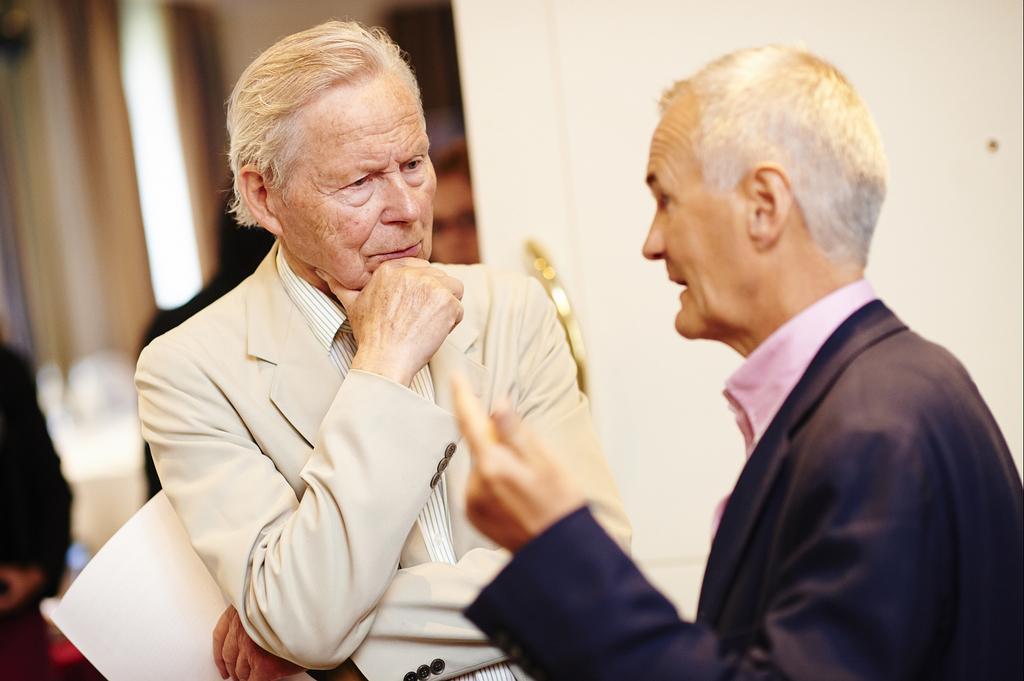Please provide a concise description of this image. In the image we can see two men standing, wearing clothes and the left side man is holding paper in hand. It looks like they are talking to each other and the background is blurred. 